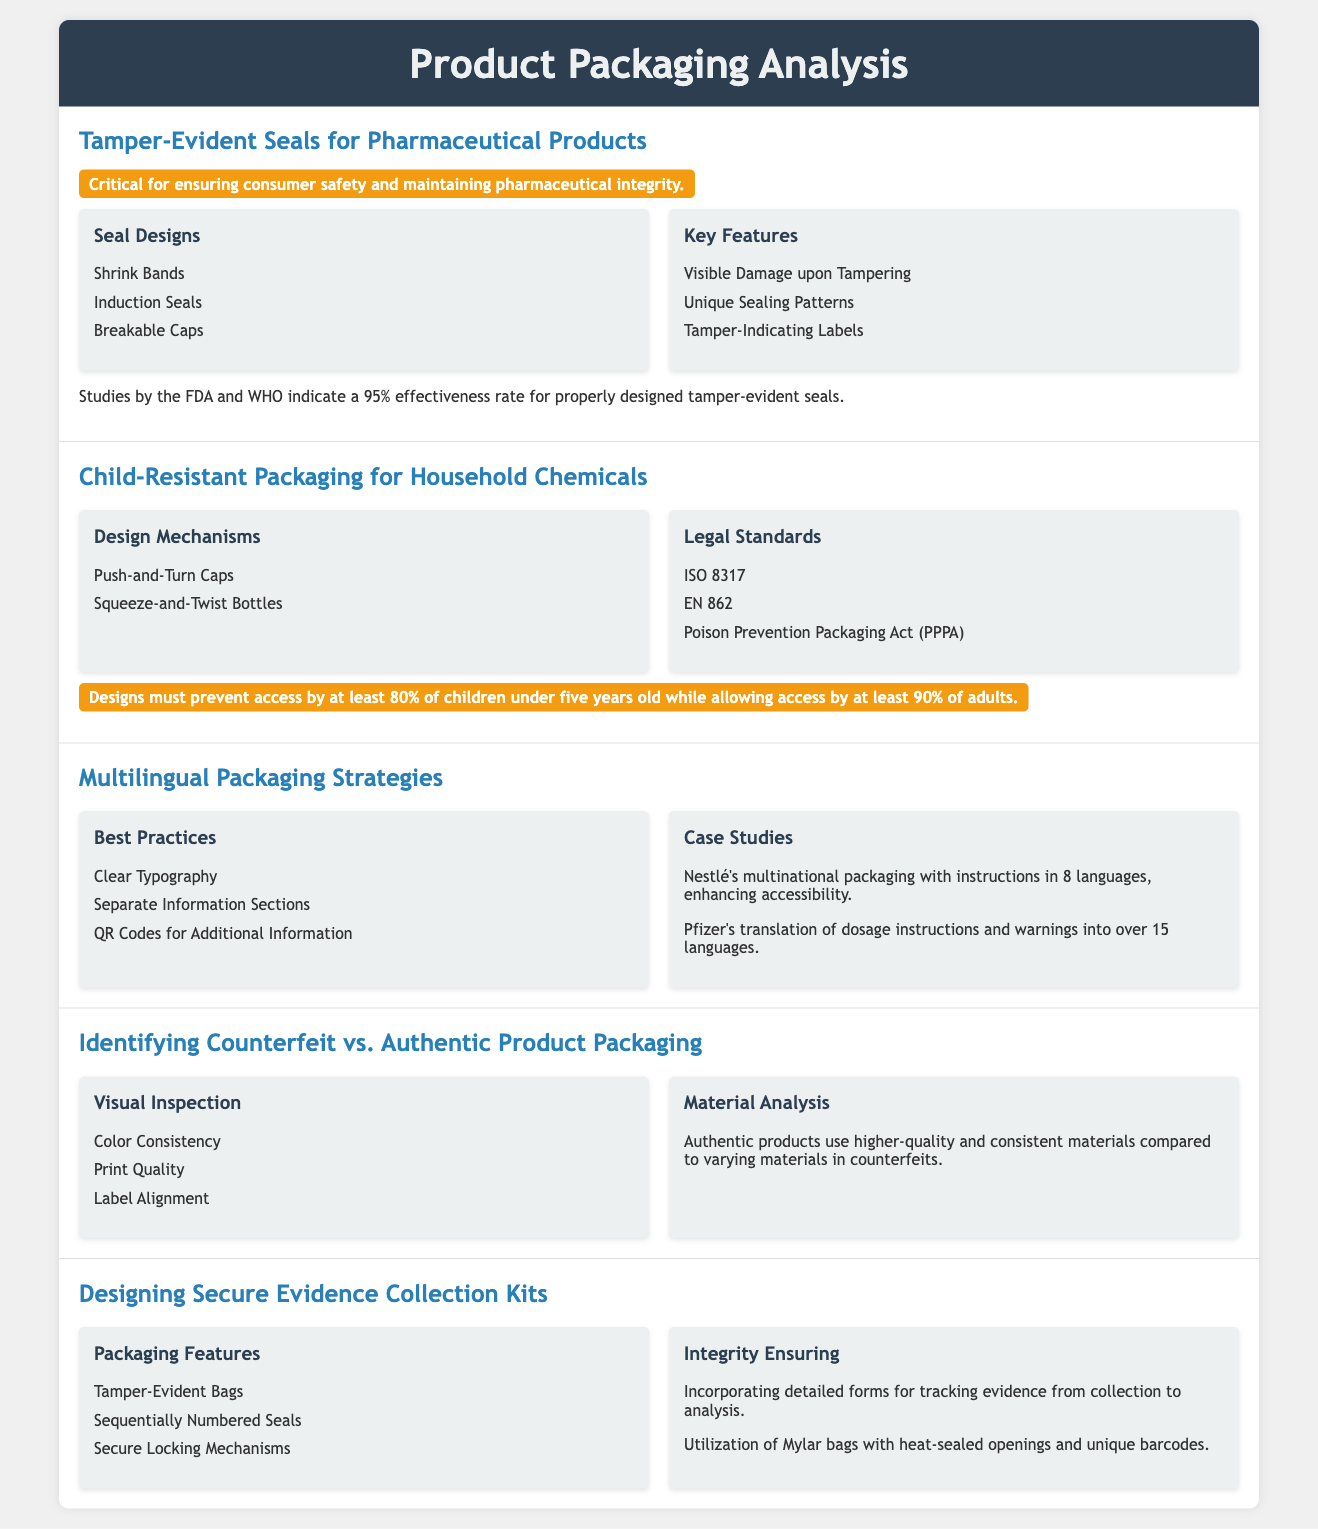What are the types of tamper-evident seals mentioned? The document lists various types of tamper-evident seals used in pharmaceutical products, including Shrink Bands, Induction Seals, and Breakable Caps.
Answer: Shrink Bands, Induction Seals, Breakable Caps What is the effectiveness rate for tamper-evident seals according to studies? The effectiveness rate for properly designed tamper-evident seals, as per studies by the FDA and WHO, is noted to be 95%.
Answer: 95% What legal standard is mentioned for child-resistant packaging? The document references multiple legal standards for designing child-resistant packaging, specifically including ISO 8317, EN 862, and the Poison Prevention Packaging Act (PPPA).
Answer: ISO 8317, EN 862, Poison Prevention Packaging Act What feature ensures child-resistant designs prevent access by children? The document states that designs must prevent access by at least 80% of children under five years old while allowing access by at least 90% of adults.
Answer: 80% What strategies are suggested for multilingual packaging? The best practices for multilingual packaging include Clear Typography, Separate Information Sections, and QR Codes for Additional Information.
Answer: Clear Typography, Separate Information Sections, QR Codes What should authentic product packaging use compared to counterfeit items? Analyzing the materials of authentic versus counterfeit goods, the document highlights that authentic products use higher-quality and consistent materials.
Answer: Higher-quality materials Which mechanism is suggested for secure evidence collection kits? The document lists several features for secure evidence collection kits, including Tamper-Evident Bags, Sequentially Numbered Seals, and Secure Locking Mechanisms.
Answer: Tamper-Evident Bags What case study is mentioned in relation to multilingual instructions? The document provides a case study of Nestlé's multinational packaging that includes instructions in 8 languages for better accessibility.
Answer: Nestlé's multinational packaging What is a highlighted benefit of tamper-evident seals? The document emphasizes that tamper-evident seals are critical for ensuring consumer safety and maintaining pharmaceutical integrity.
Answer: Consumer safety and integrity 